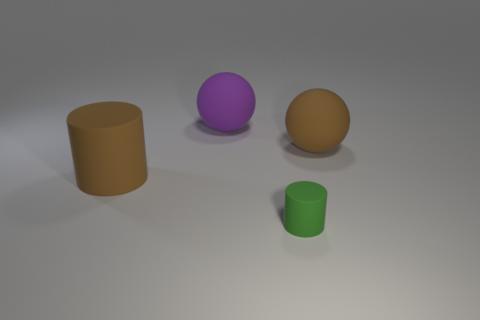Are there any other things that are the same size as the green cylinder?
Ensure brevity in your answer.  No. There is a thing that is the same color as the large matte cylinder; what material is it?
Make the answer very short. Rubber. How many brown rubber things are the same shape as the green object?
Give a very brief answer. 1. There is a cylinder right of the brown matte cylinder; is its color the same as the thing to the right of the small matte thing?
Ensure brevity in your answer.  No. What is the material of the brown thing that is the same size as the brown rubber cylinder?
Your answer should be compact. Rubber. Are there any blue cylinders that have the same size as the green object?
Give a very brief answer. No. Is the number of large brown cylinders in front of the small cylinder less than the number of green metal things?
Offer a terse response. No. Are there fewer purple things that are on the left side of the big rubber cylinder than tiny matte cylinders that are behind the tiny cylinder?
Keep it short and to the point. No. How many cylinders are large green matte things or matte objects?
Your response must be concise. 2. Is the material of the object in front of the brown rubber cylinder the same as the big ball that is behind the brown ball?
Your answer should be very brief. Yes. 